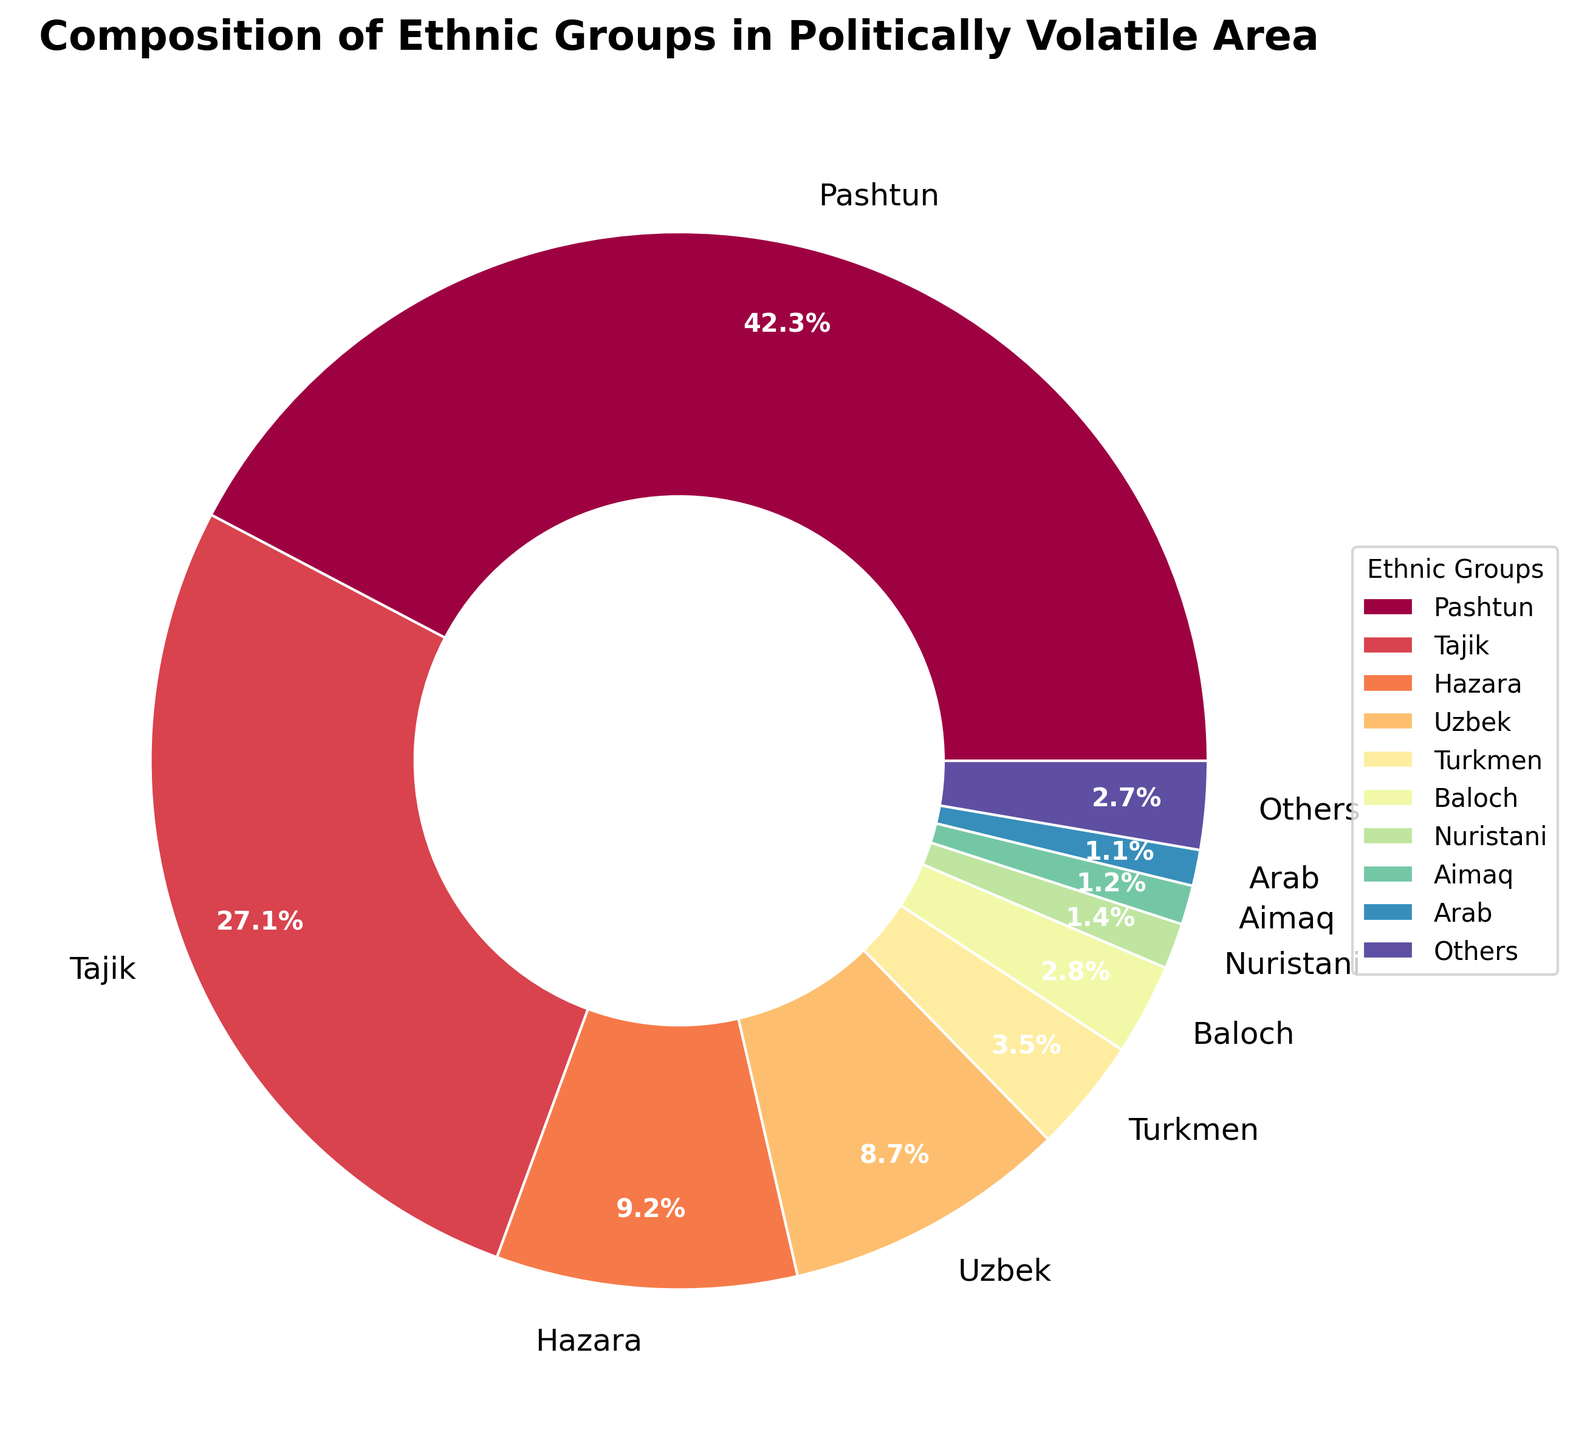What is the percentage of the largest ethnic group? The largest ethnic group in the chart is the Pashtun. The figure shows that the Pashtun group holds a percentage of 42.3%.
Answer: 42.3% Which group is the second largest, and what is their percentage? By examining the chart, the second largest ethnic group is the Tajik, with a percentage of 27.1%.
Answer: Tajik, 27.1% What is the combined percentage of Hazara and Uzbek groups? The chart indicates that the Hazara group has 9.2% and the Uzbek group has 8.7%. Adding these percentages together gives 9.2 + 8.7 = 17.9%.
Answer: 17.9% How does the percentage of the Turkmen group compare to that of the Nuristani group? The percentage for the Turkmen group is 3.5%, while for the Nuristani group, it is 1.4%. Therefore, the Turkmen percentage is higher than that of the Nuristani.
Answer: Turkmen percentage is higher What is the color of the ‘Others’ category in the pie chart? Considering the generated plot, the 'Others' category should be represented by a distinct color as per the color palette. The exact color will vary depending on the specific color mapping used in the `plt.cm.Spectral` function, but it would typically be easy to identify visually in the chart's legend.
Answer: (Answer will depend on visual inspection) Which ethnic group has a percentage just above 1%? The chart shows that the Nuristani group has 1.4%, which is the closest percentage above 1%.
Answer: Nuristani What is the sum of all the groups with at least 1% each? Summing the percentages of the groups with at least 1%: Pashtun (42.3), Tajik (27.1), Hazara (9.2), Uzbek (8.7), Turkmen (3.5), Baloch (2.8), Nuristani (1.4), Aimaq (1.2), Arab (1.1) results in 97.3%.
Answer: 97.3% Which two groups have the smallest differences in their percentages? By calculating the differences between the percentages of each group: The smallest difference is between Hazara (9.2%) and Uzbek (8.7%), which is 0.5%.
Answer: Hazara and Uzbek What is the approximate sum of the percentages of all groups labeled directly, excluding the 'Others' category? Summing all the directly labeled groups excluding 'Others': 42.3 (Pashtun) + 27.1 (Tajik) + 9.2 (Hazara) + 8.7 (Uzbek) + 3.5 (Turkmen) + 2.8 (Baloch) + 1.4 (Nuristani) + 1.2 (Aimaq) + 1.1 (Arab) gives us an approximate sum of 97.3%.
Answer: 97.3% What percentage does the 'Others' category represent? The 'Others' category represents the remaining percentage after accounting for all groups above 1%. Summing up the percentages of all mentioned groups gives 97.3%, meaning 'Others' is 100 - 97.3 = 2.7%.
Answer: 2.7% 